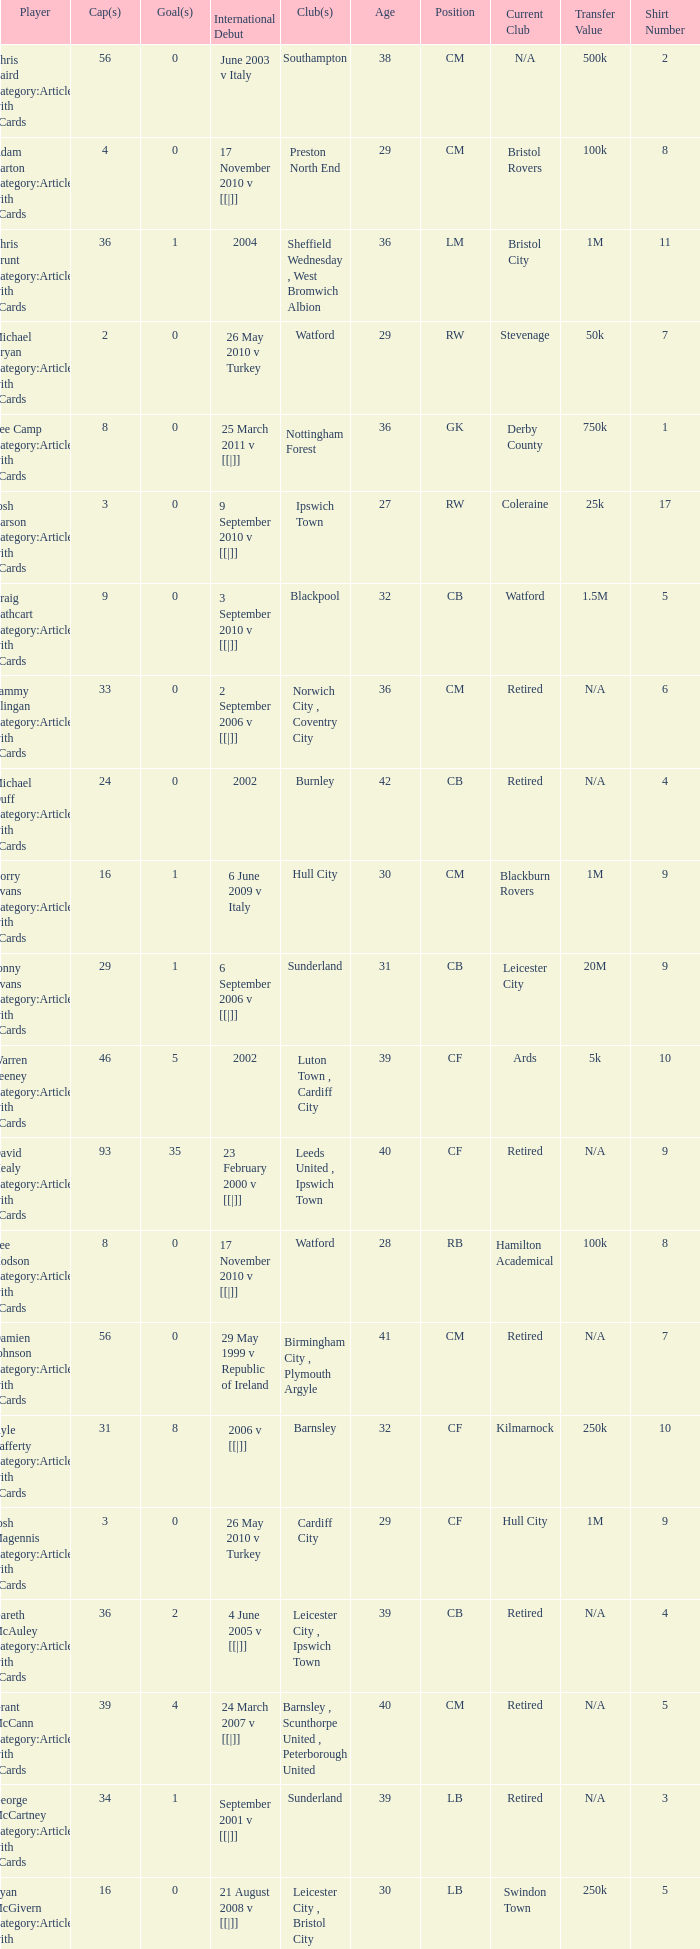How many players had 8 goals? 1.0. 